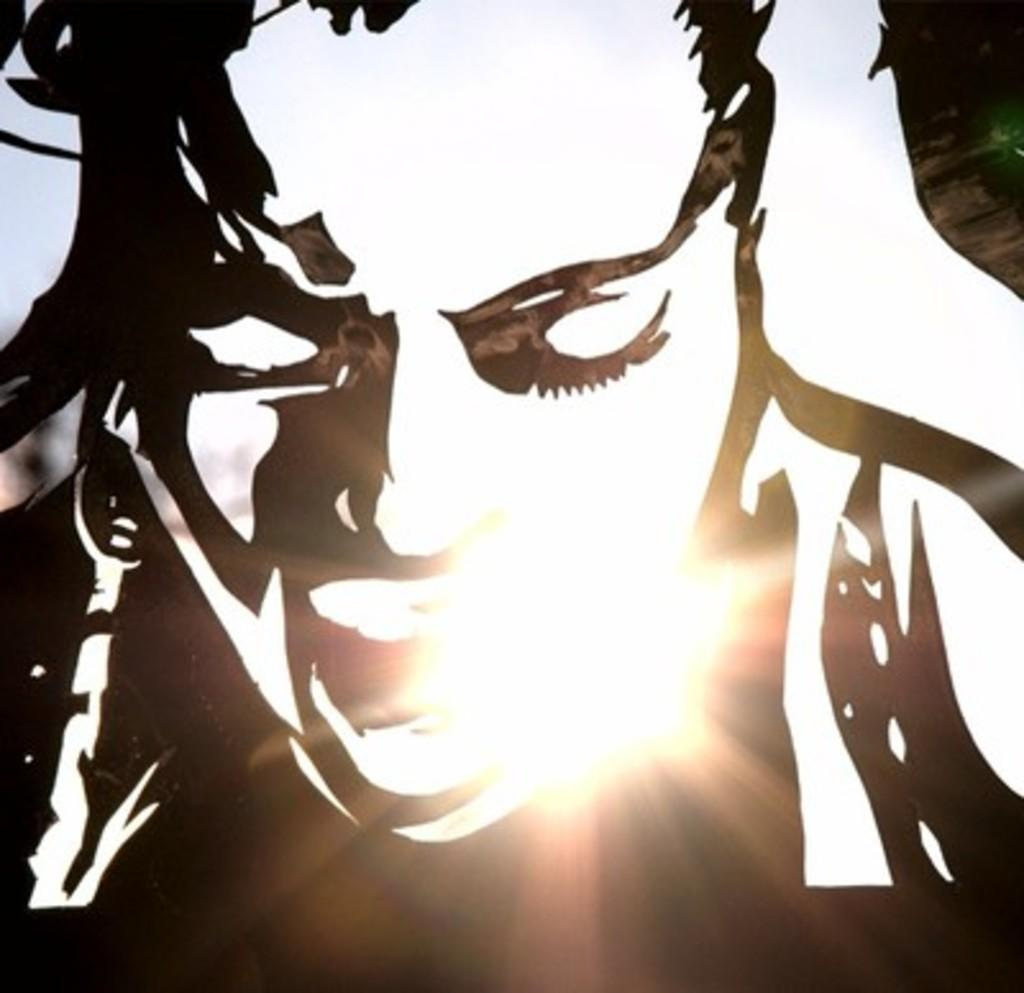What type of image is this? The image is an edited image of a person. What type of cave can be seen in the background of the image? There is no cave present in the image, as it is an edited image of a person. How many sheep are visible in the image? There are no sheep present in the image, as it is an edited image of a person. 